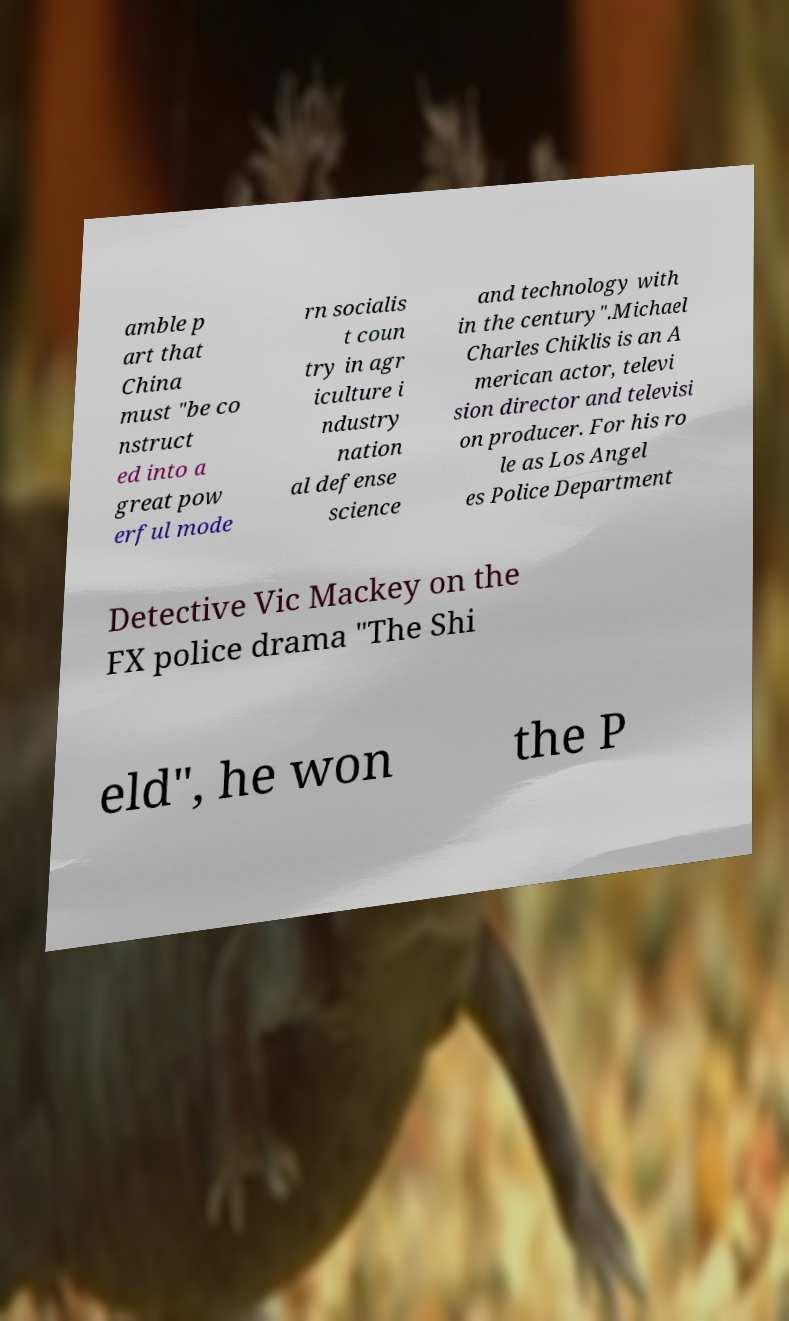Can you read and provide the text displayed in the image?This photo seems to have some interesting text. Can you extract and type it out for me? amble p art that China must "be co nstruct ed into a great pow erful mode rn socialis t coun try in agr iculture i ndustry nation al defense science and technology with in the century".Michael Charles Chiklis is an A merican actor, televi sion director and televisi on producer. For his ro le as Los Angel es Police Department Detective Vic Mackey on the FX police drama "The Shi eld", he won the P 